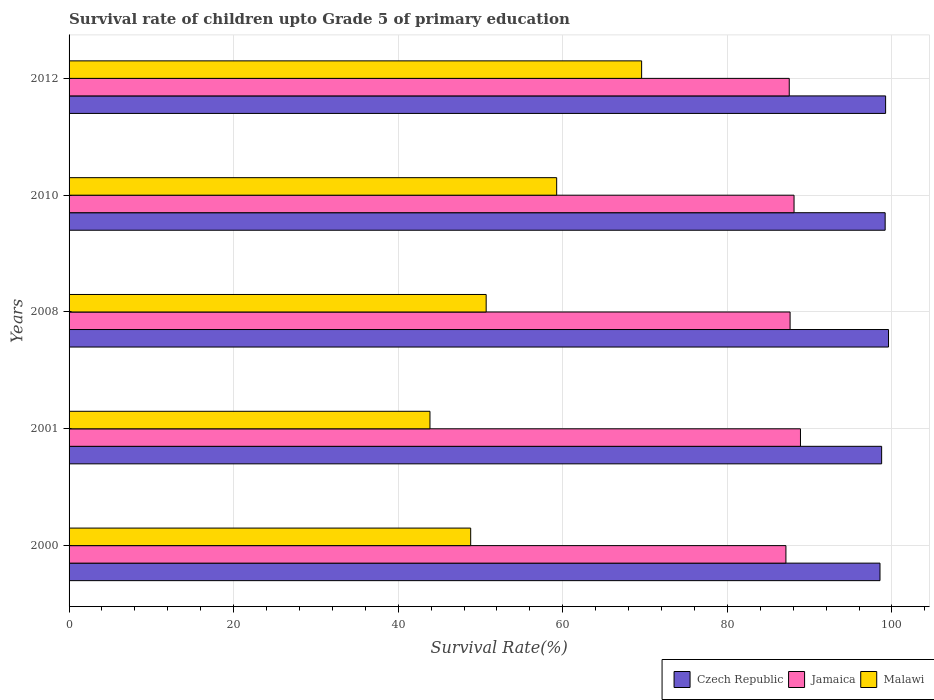How many different coloured bars are there?
Give a very brief answer. 3. How many groups of bars are there?
Your response must be concise. 5. Are the number of bars per tick equal to the number of legend labels?
Your answer should be compact. Yes. How many bars are there on the 4th tick from the bottom?
Give a very brief answer. 3. What is the survival rate of children in Czech Republic in 2012?
Ensure brevity in your answer.  99.23. Across all years, what is the maximum survival rate of children in Czech Republic?
Make the answer very short. 99.58. Across all years, what is the minimum survival rate of children in Malawi?
Your response must be concise. 43.86. In which year was the survival rate of children in Jamaica minimum?
Provide a succinct answer. 2000. What is the total survival rate of children in Jamaica in the graph?
Give a very brief answer. 439.24. What is the difference between the survival rate of children in Czech Republic in 2000 and that in 2012?
Your answer should be very brief. -0.68. What is the difference between the survival rate of children in Malawi in 2010 and the survival rate of children in Czech Republic in 2000?
Your answer should be compact. -39.29. What is the average survival rate of children in Malawi per year?
Your answer should be very brief. 54.44. In the year 2010, what is the difference between the survival rate of children in Malawi and survival rate of children in Jamaica?
Your answer should be compact. -28.85. In how many years, is the survival rate of children in Czech Republic greater than 92 %?
Give a very brief answer. 5. What is the ratio of the survival rate of children in Malawi in 2001 to that in 2012?
Your answer should be compact. 0.63. Is the survival rate of children in Malawi in 2008 less than that in 2012?
Offer a very short reply. Yes. Is the difference between the survival rate of children in Malawi in 2000 and 2010 greater than the difference between the survival rate of children in Jamaica in 2000 and 2010?
Ensure brevity in your answer.  No. What is the difference between the highest and the second highest survival rate of children in Malawi?
Make the answer very short. 10.32. What is the difference between the highest and the lowest survival rate of children in Malawi?
Your response must be concise. 25.72. In how many years, is the survival rate of children in Malawi greater than the average survival rate of children in Malawi taken over all years?
Ensure brevity in your answer.  2. What does the 1st bar from the top in 2008 represents?
Make the answer very short. Malawi. What does the 3rd bar from the bottom in 2010 represents?
Your answer should be very brief. Malawi. What is the difference between two consecutive major ticks on the X-axis?
Offer a very short reply. 20. Are the values on the major ticks of X-axis written in scientific E-notation?
Your answer should be very brief. No. Does the graph contain any zero values?
Ensure brevity in your answer.  No. Does the graph contain grids?
Your response must be concise. Yes. Where does the legend appear in the graph?
Ensure brevity in your answer.  Bottom right. How many legend labels are there?
Keep it short and to the point. 3. How are the legend labels stacked?
Your response must be concise. Horizontal. What is the title of the graph?
Give a very brief answer. Survival rate of children upto Grade 5 of primary education. Does "Northern Mariana Islands" appear as one of the legend labels in the graph?
Give a very brief answer. No. What is the label or title of the X-axis?
Offer a terse response. Survival Rate(%). What is the Survival Rate(%) in Czech Republic in 2000?
Provide a succinct answer. 98.55. What is the Survival Rate(%) of Jamaica in 2000?
Keep it short and to the point. 87.12. What is the Survival Rate(%) in Malawi in 2000?
Give a very brief answer. 48.81. What is the Survival Rate(%) in Czech Republic in 2001?
Ensure brevity in your answer.  98.75. What is the Survival Rate(%) in Jamaica in 2001?
Provide a short and direct response. 88.88. What is the Survival Rate(%) in Malawi in 2001?
Your response must be concise. 43.86. What is the Survival Rate(%) in Czech Republic in 2008?
Offer a terse response. 99.58. What is the Survival Rate(%) of Jamaica in 2008?
Offer a terse response. 87.62. What is the Survival Rate(%) of Malawi in 2008?
Your answer should be compact. 50.69. What is the Survival Rate(%) in Czech Republic in 2010?
Your answer should be compact. 99.18. What is the Survival Rate(%) in Jamaica in 2010?
Your answer should be very brief. 88.1. What is the Survival Rate(%) of Malawi in 2010?
Your response must be concise. 59.26. What is the Survival Rate(%) in Czech Republic in 2012?
Your answer should be compact. 99.23. What is the Survival Rate(%) of Jamaica in 2012?
Provide a short and direct response. 87.52. What is the Survival Rate(%) in Malawi in 2012?
Your response must be concise. 69.58. Across all years, what is the maximum Survival Rate(%) in Czech Republic?
Give a very brief answer. 99.58. Across all years, what is the maximum Survival Rate(%) in Jamaica?
Keep it short and to the point. 88.88. Across all years, what is the maximum Survival Rate(%) of Malawi?
Your answer should be very brief. 69.58. Across all years, what is the minimum Survival Rate(%) of Czech Republic?
Your answer should be compact. 98.55. Across all years, what is the minimum Survival Rate(%) of Jamaica?
Your answer should be compact. 87.12. Across all years, what is the minimum Survival Rate(%) of Malawi?
Your answer should be compact. 43.86. What is the total Survival Rate(%) of Czech Republic in the graph?
Ensure brevity in your answer.  495.29. What is the total Survival Rate(%) of Jamaica in the graph?
Keep it short and to the point. 439.25. What is the total Survival Rate(%) in Malawi in the graph?
Offer a very short reply. 272.19. What is the difference between the Survival Rate(%) in Czech Republic in 2000 and that in 2001?
Ensure brevity in your answer.  -0.2. What is the difference between the Survival Rate(%) in Jamaica in 2000 and that in 2001?
Keep it short and to the point. -1.77. What is the difference between the Survival Rate(%) of Malawi in 2000 and that in 2001?
Give a very brief answer. 4.95. What is the difference between the Survival Rate(%) in Czech Republic in 2000 and that in 2008?
Provide a short and direct response. -1.03. What is the difference between the Survival Rate(%) of Jamaica in 2000 and that in 2008?
Keep it short and to the point. -0.51. What is the difference between the Survival Rate(%) in Malawi in 2000 and that in 2008?
Ensure brevity in your answer.  -1.88. What is the difference between the Survival Rate(%) in Czech Republic in 2000 and that in 2010?
Make the answer very short. -0.63. What is the difference between the Survival Rate(%) in Jamaica in 2000 and that in 2010?
Provide a short and direct response. -0.99. What is the difference between the Survival Rate(%) in Malawi in 2000 and that in 2010?
Give a very brief answer. -10.45. What is the difference between the Survival Rate(%) in Czech Republic in 2000 and that in 2012?
Keep it short and to the point. -0.68. What is the difference between the Survival Rate(%) in Jamaica in 2000 and that in 2012?
Offer a very short reply. -0.41. What is the difference between the Survival Rate(%) in Malawi in 2000 and that in 2012?
Give a very brief answer. -20.77. What is the difference between the Survival Rate(%) of Czech Republic in 2001 and that in 2008?
Keep it short and to the point. -0.84. What is the difference between the Survival Rate(%) of Jamaica in 2001 and that in 2008?
Your answer should be compact. 1.26. What is the difference between the Survival Rate(%) in Malawi in 2001 and that in 2008?
Make the answer very short. -6.83. What is the difference between the Survival Rate(%) of Czech Republic in 2001 and that in 2010?
Your answer should be very brief. -0.43. What is the difference between the Survival Rate(%) of Jamaica in 2001 and that in 2010?
Your response must be concise. 0.78. What is the difference between the Survival Rate(%) of Malawi in 2001 and that in 2010?
Your response must be concise. -15.4. What is the difference between the Survival Rate(%) in Czech Republic in 2001 and that in 2012?
Offer a very short reply. -0.48. What is the difference between the Survival Rate(%) in Jamaica in 2001 and that in 2012?
Offer a very short reply. 1.36. What is the difference between the Survival Rate(%) of Malawi in 2001 and that in 2012?
Keep it short and to the point. -25.72. What is the difference between the Survival Rate(%) of Czech Republic in 2008 and that in 2010?
Ensure brevity in your answer.  0.41. What is the difference between the Survival Rate(%) of Jamaica in 2008 and that in 2010?
Give a very brief answer. -0.48. What is the difference between the Survival Rate(%) in Malawi in 2008 and that in 2010?
Make the answer very short. -8.57. What is the difference between the Survival Rate(%) in Czech Republic in 2008 and that in 2012?
Your response must be concise. 0.35. What is the difference between the Survival Rate(%) of Jamaica in 2008 and that in 2012?
Your answer should be compact. 0.1. What is the difference between the Survival Rate(%) in Malawi in 2008 and that in 2012?
Provide a succinct answer. -18.89. What is the difference between the Survival Rate(%) of Czech Republic in 2010 and that in 2012?
Make the answer very short. -0.05. What is the difference between the Survival Rate(%) of Jamaica in 2010 and that in 2012?
Offer a terse response. 0.58. What is the difference between the Survival Rate(%) of Malawi in 2010 and that in 2012?
Your answer should be compact. -10.32. What is the difference between the Survival Rate(%) of Czech Republic in 2000 and the Survival Rate(%) of Jamaica in 2001?
Ensure brevity in your answer.  9.67. What is the difference between the Survival Rate(%) in Czech Republic in 2000 and the Survival Rate(%) in Malawi in 2001?
Offer a very short reply. 54.69. What is the difference between the Survival Rate(%) in Jamaica in 2000 and the Survival Rate(%) in Malawi in 2001?
Offer a very short reply. 43.26. What is the difference between the Survival Rate(%) in Czech Republic in 2000 and the Survival Rate(%) in Jamaica in 2008?
Your answer should be very brief. 10.93. What is the difference between the Survival Rate(%) of Czech Republic in 2000 and the Survival Rate(%) of Malawi in 2008?
Give a very brief answer. 47.86. What is the difference between the Survival Rate(%) of Jamaica in 2000 and the Survival Rate(%) of Malawi in 2008?
Provide a short and direct response. 36.43. What is the difference between the Survival Rate(%) of Czech Republic in 2000 and the Survival Rate(%) of Jamaica in 2010?
Your response must be concise. 10.45. What is the difference between the Survival Rate(%) of Czech Republic in 2000 and the Survival Rate(%) of Malawi in 2010?
Make the answer very short. 39.29. What is the difference between the Survival Rate(%) in Jamaica in 2000 and the Survival Rate(%) in Malawi in 2010?
Give a very brief answer. 27.86. What is the difference between the Survival Rate(%) of Czech Republic in 2000 and the Survival Rate(%) of Jamaica in 2012?
Your response must be concise. 11.03. What is the difference between the Survival Rate(%) in Czech Republic in 2000 and the Survival Rate(%) in Malawi in 2012?
Your answer should be very brief. 28.97. What is the difference between the Survival Rate(%) of Jamaica in 2000 and the Survival Rate(%) of Malawi in 2012?
Ensure brevity in your answer.  17.53. What is the difference between the Survival Rate(%) in Czech Republic in 2001 and the Survival Rate(%) in Jamaica in 2008?
Your response must be concise. 11.13. What is the difference between the Survival Rate(%) in Czech Republic in 2001 and the Survival Rate(%) in Malawi in 2008?
Your response must be concise. 48.06. What is the difference between the Survival Rate(%) in Jamaica in 2001 and the Survival Rate(%) in Malawi in 2008?
Your response must be concise. 38.2. What is the difference between the Survival Rate(%) of Czech Republic in 2001 and the Survival Rate(%) of Jamaica in 2010?
Provide a succinct answer. 10.65. What is the difference between the Survival Rate(%) of Czech Republic in 2001 and the Survival Rate(%) of Malawi in 2010?
Provide a short and direct response. 39.49. What is the difference between the Survival Rate(%) in Jamaica in 2001 and the Survival Rate(%) in Malawi in 2010?
Offer a very short reply. 29.63. What is the difference between the Survival Rate(%) of Czech Republic in 2001 and the Survival Rate(%) of Jamaica in 2012?
Offer a terse response. 11.23. What is the difference between the Survival Rate(%) in Czech Republic in 2001 and the Survival Rate(%) in Malawi in 2012?
Give a very brief answer. 29.17. What is the difference between the Survival Rate(%) of Jamaica in 2001 and the Survival Rate(%) of Malawi in 2012?
Keep it short and to the point. 19.3. What is the difference between the Survival Rate(%) in Czech Republic in 2008 and the Survival Rate(%) in Jamaica in 2010?
Offer a very short reply. 11.48. What is the difference between the Survival Rate(%) in Czech Republic in 2008 and the Survival Rate(%) in Malawi in 2010?
Keep it short and to the point. 40.33. What is the difference between the Survival Rate(%) of Jamaica in 2008 and the Survival Rate(%) of Malawi in 2010?
Your answer should be very brief. 28.37. What is the difference between the Survival Rate(%) in Czech Republic in 2008 and the Survival Rate(%) in Jamaica in 2012?
Provide a short and direct response. 12.06. What is the difference between the Survival Rate(%) of Czech Republic in 2008 and the Survival Rate(%) of Malawi in 2012?
Provide a succinct answer. 30. What is the difference between the Survival Rate(%) in Jamaica in 2008 and the Survival Rate(%) in Malawi in 2012?
Your answer should be very brief. 18.04. What is the difference between the Survival Rate(%) in Czech Republic in 2010 and the Survival Rate(%) in Jamaica in 2012?
Your answer should be very brief. 11.66. What is the difference between the Survival Rate(%) in Czech Republic in 2010 and the Survival Rate(%) in Malawi in 2012?
Offer a very short reply. 29.6. What is the difference between the Survival Rate(%) of Jamaica in 2010 and the Survival Rate(%) of Malawi in 2012?
Your answer should be very brief. 18.52. What is the average Survival Rate(%) of Czech Republic per year?
Your response must be concise. 99.06. What is the average Survival Rate(%) of Jamaica per year?
Ensure brevity in your answer.  87.85. What is the average Survival Rate(%) of Malawi per year?
Your response must be concise. 54.44. In the year 2000, what is the difference between the Survival Rate(%) in Czech Republic and Survival Rate(%) in Jamaica?
Give a very brief answer. 11.43. In the year 2000, what is the difference between the Survival Rate(%) in Czech Republic and Survival Rate(%) in Malawi?
Keep it short and to the point. 49.74. In the year 2000, what is the difference between the Survival Rate(%) in Jamaica and Survival Rate(%) in Malawi?
Make the answer very short. 38.31. In the year 2001, what is the difference between the Survival Rate(%) of Czech Republic and Survival Rate(%) of Jamaica?
Provide a short and direct response. 9.87. In the year 2001, what is the difference between the Survival Rate(%) of Czech Republic and Survival Rate(%) of Malawi?
Your answer should be compact. 54.89. In the year 2001, what is the difference between the Survival Rate(%) of Jamaica and Survival Rate(%) of Malawi?
Provide a short and direct response. 45.02. In the year 2008, what is the difference between the Survival Rate(%) of Czech Republic and Survival Rate(%) of Jamaica?
Provide a short and direct response. 11.96. In the year 2008, what is the difference between the Survival Rate(%) of Czech Republic and Survival Rate(%) of Malawi?
Your response must be concise. 48.9. In the year 2008, what is the difference between the Survival Rate(%) of Jamaica and Survival Rate(%) of Malawi?
Provide a succinct answer. 36.94. In the year 2010, what is the difference between the Survival Rate(%) of Czech Republic and Survival Rate(%) of Jamaica?
Give a very brief answer. 11.07. In the year 2010, what is the difference between the Survival Rate(%) of Czech Republic and Survival Rate(%) of Malawi?
Your answer should be compact. 39.92. In the year 2010, what is the difference between the Survival Rate(%) of Jamaica and Survival Rate(%) of Malawi?
Provide a succinct answer. 28.85. In the year 2012, what is the difference between the Survival Rate(%) of Czech Republic and Survival Rate(%) of Jamaica?
Give a very brief answer. 11.71. In the year 2012, what is the difference between the Survival Rate(%) of Czech Republic and Survival Rate(%) of Malawi?
Offer a very short reply. 29.65. In the year 2012, what is the difference between the Survival Rate(%) of Jamaica and Survival Rate(%) of Malawi?
Provide a succinct answer. 17.94. What is the ratio of the Survival Rate(%) in Jamaica in 2000 to that in 2001?
Make the answer very short. 0.98. What is the ratio of the Survival Rate(%) of Malawi in 2000 to that in 2001?
Provide a short and direct response. 1.11. What is the ratio of the Survival Rate(%) in Czech Republic in 2000 to that in 2008?
Make the answer very short. 0.99. What is the ratio of the Survival Rate(%) in Jamaica in 2000 to that in 2008?
Provide a short and direct response. 0.99. What is the ratio of the Survival Rate(%) of Malawi in 2000 to that in 2008?
Provide a short and direct response. 0.96. What is the ratio of the Survival Rate(%) in Malawi in 2000 to that in 2010?
Provide a short and direct response. 0.82. What is the ratio of the Survival Rate(%) in Czech Republic in 2000 to that in 2012?
Your answer should be very brief. 0.99. What is the ratio of the Survival Rate(%) of Malawi in 2000 to that in 2012?
Provide a succinct answer. 0.7. What is the ratio of the Survival Rate(%) of Jamaica in 2001 to that in 2008?
Your response must be concise. 1.01. What is the ratio of the Survival Rate(%) in Malawi in 2001 to that in 2008?
Your response must be concise. 0.87. What is the ratio of the Survival Rate(%) of Czech Republic in 2001 to that in 2010?
Your response must be concise. 1. What is the ratio of the Survival Rate(%) of Jamaica in 2001 to that in 2010?
Your answer should be compact. 1.01. What is the ratio of the Survival Rate(%) of Malawi in 2001 to that in 2010?
Make the answer very short. 0.74. What is the ratio of the Survival Rate(%) of Jamaica in 2001 to that in 2012?
Keep it short and to the point. 1.02. What is the ratio of the Survival Rate(%) of Malawi in 2001 to that in 2012?
Make the answer very short. 0.63. What is the ratio of the Survival Rate(%) in Czech Republic in 2008 to that in 2010?
Your response must be concise. 1. What is the ratio of the Survival Rate(%) in Malawi in 2008 to that in 2010?
Give a very brief answer. 0.86. What is the ratio of the Survival Rate(%) in Czech Republic in 2008 to that in 2012?
Provide a short and direct response. 1. What is the ratio of the Survival Rate(%) of Jamaica in 2008 to that in 2012?
Provide a short and direct response. 1. What is the ratio of the Survival Rate(%) in Malawi in 2008 to that in 2012?
Provide a short and direct response. 0.73. What is the ratio of the Survival Rate(%) of Czech Republic in 2010 to that in 2012?
Provide a short and direct response. 1. What is the ratio of the Survival Rate(%) of Jamaica in 2010 to that in 2012?
Give a very brief answer. 1.01. What is the ratio of the Survival Rate(%) of Malawi in 2010 to that in 2012?
Your answer should be very brief. 0.85. What is the difference between the highest and the second highest Survival Rate(%) in Czech Republic?
Offer a very short reply. 0.35. What is the difference between the highest and the second highest Survival Rate(%) in Jamaica?
Ensure brevity in your answer.  0.78. What is the difference between the highest and the second highest Survival Rate(%) of Malawi?
Ensure brevity in your answer.  10.32. What is the difference between the highest and the lowest Survival Rate(%) in Czech Republic?
Offer a very short reply. 1.03. What is the difference between the highest and the lowest Survival Rate(%) of Jamaica?
Offer a very short reply. 1.77. What is the difference between the highest and the lowest Survival Rate(%) in Malawi?
Make the answer very short. 25.72. 